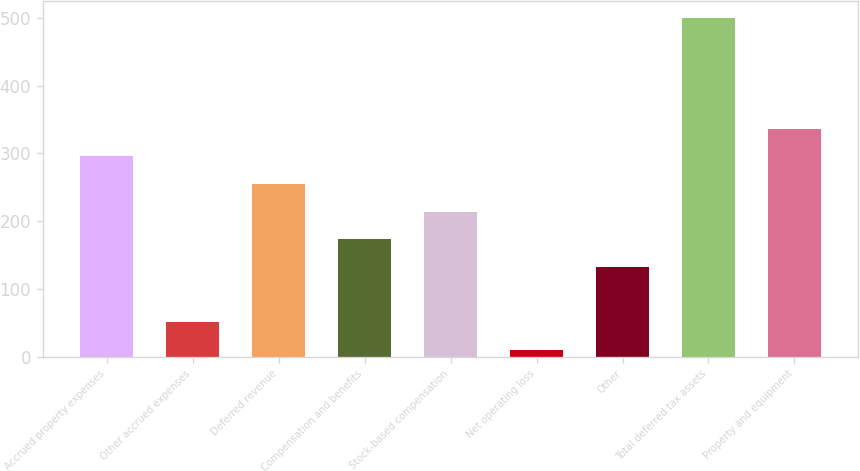Convert chart to OTSL. <chart><loc_0><loc_0><loc_500><loc_500><bar_chart><fcel>Accrued property expenses<fcel>Other accrued expenses<fcel>Deferred revenue<fcel>Compensation and benefits<fcel>Stock-based compensation<fcel>Net operating loss<fcel>Other<fcel>Total deferred tax assets<fcel>Property and equipment<nl><fcel>295.6<fcel>50.8<fcel>254.8<fcel>173.2<fcel>214<fcel>10<fcel>132.4<fcel>499.6<fcel>336.4<nl></chart> 